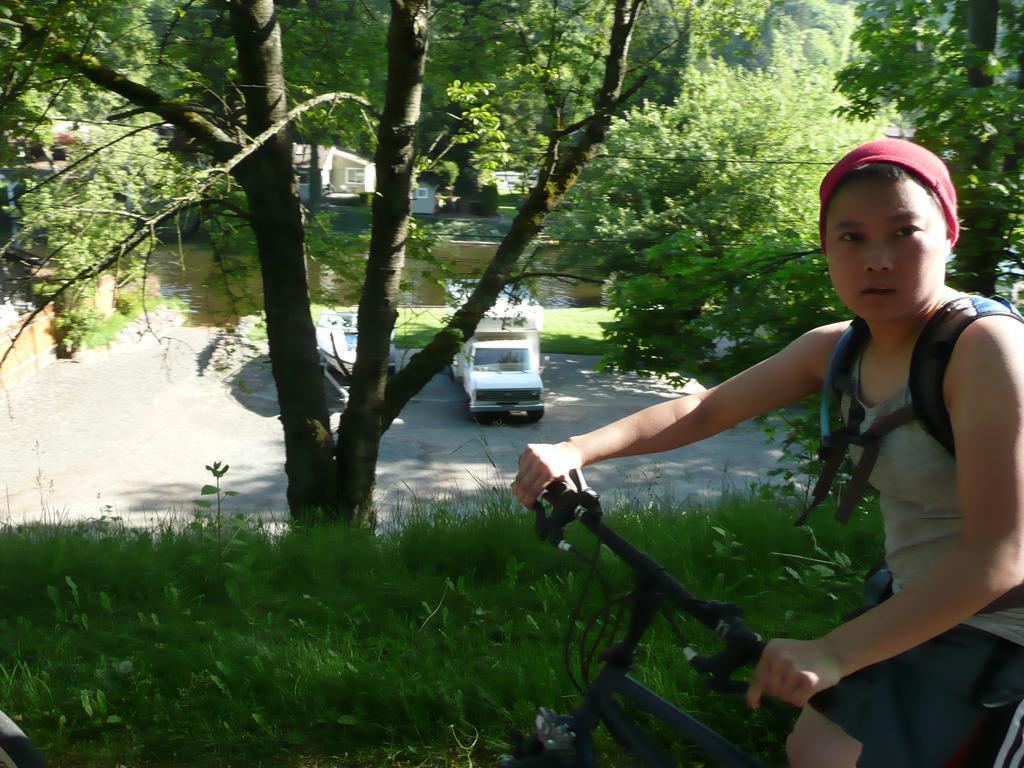Can you describe this image briefly? As we can see in the image, there is a tree, a truck on road, grass and a boy on bicycle. 